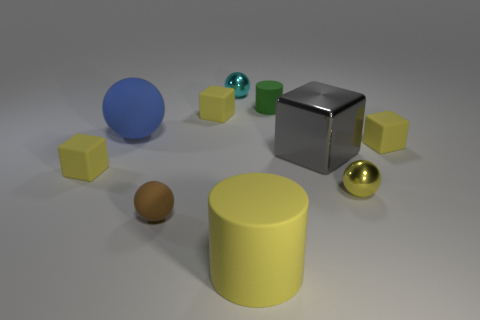There is another rubber thing that is the same shape as the blue rubber thing; what is its color?
Make the answer very short. Brown. What is the shape of the big rubber object in front of the small yellow thing that is right of the tiny ball right of the yellow rubber cylinder?
Make the answer very short. Cylinder. Is the shape of the small green object the same as the big yellow thing?
Make the answer very short. Yes. There is a large matte thing behind the metallic sphere to the right of the cyan ball; what is its shape?
Keep it short and to the point. Sphere. Is there a big cyan block?
Provide a succinct answer. No. What number of tiny rubber cubes are in front of the small brown sphere that is left of the thing that is behind the small green matte cylinder?
Provide a succinct answer. 0. Is the shape of the green thing the same as the big rubber thing that is in front of the brown rubber sphere?
Make the answer very short. Yes. Is the number of tiny yellow metal spheres greater than the number of yellow cubes?
Provide a succinct answer. No. Does the big thing that is on the left side of the small brown object have the same shape as the brown thing?
Give a very brief answer. Yes. Is the number of big matte balls on the right side of the blue rubber sphere greater than the number of tiny brown spheres?
Offer a very short reply. No. 